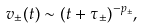<formula> <loc_0><loc_0><loc_500><loc_500>v _ { \pm } ( t ) \sim ( t + \tau _ { \pm } ) ^ { - p _ { \pm } } ,</formula> 